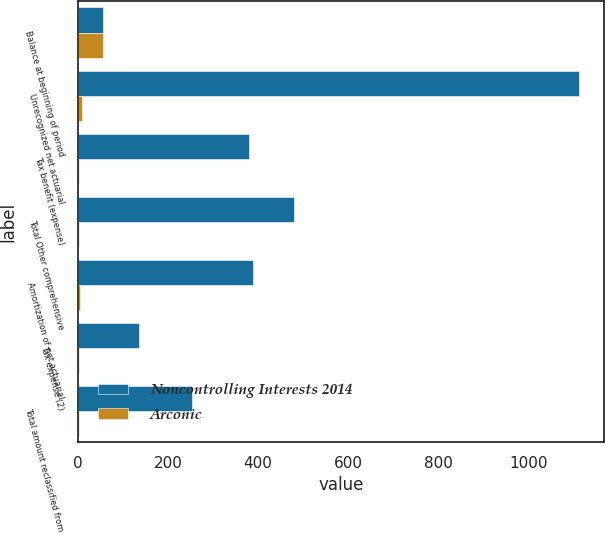<chart> <loc_0><loc_0><loc_500><loc_500><stacked_bar_chart><ecel><fcel>Balance at beginning of period<fcel>Unrecognized net actuarial<fcel>Tax benefit (expense)<fcel>Total Other comprehensive<fcel>Amortization of net actuarial<fcel>Tax expense (2)<fcel>Total amount reclassified from<nl><fcel>Noncontrolling Interests 2014<fcel>56<fcel>1112<fcel>380<fcel>479<fcel>389<fcel>136<fcel>253<nl><fcel>Arconic<fcel>56<fcel>9<fcel>3<fcel>3<fcel>4<fcel>1<fcel>3<nl></chart> 